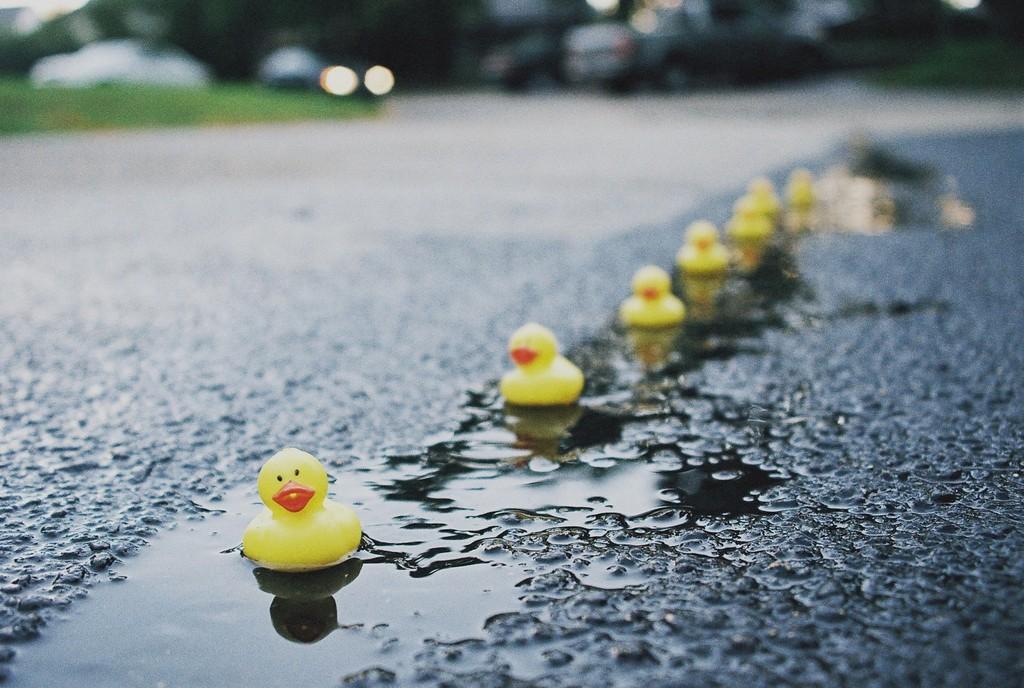In one or two sentences, can you explain what this image depicts? In this picture there are toy ducks on the floor, in the series and there are cars and trees at the top side of the image. 